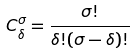Convert formula to latex. <formula><loc_0><loc_0><loc_500><loc_500>C _ { \delta } ^ { \sigma } = \frac { \sigma ! } { \delta ! ( \sigma - \delta ) ! }</formula> 